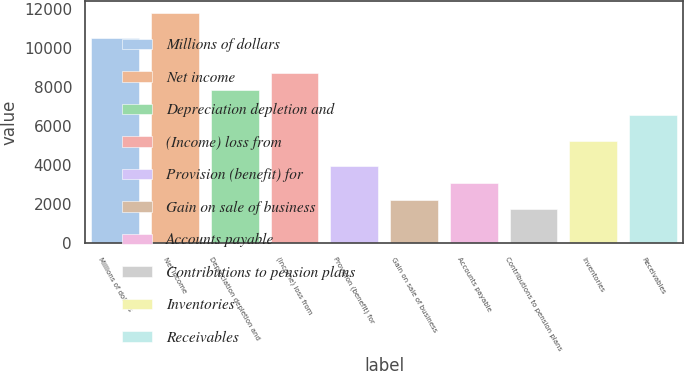<chart> <loc_0><loc_0><loc_500><loc_500><bar_chart><fcel>Millions of dollars<fcel>Net income<fcel>Depreciation depletion and<fcel>(Income) loss from<fcel>Provision (benefit) for<fcel>Gain on sale of business<fcel>Accounts payable<fcel>Contributions to pension plans<fcel>Inventories<fcel>Receivables<nl><fcel>10499.8<fcel>11811.4<fcel>7876.6<fcel>8751<fcel>3941.8<fcel>2193<fcel>3067.4<fcel>1755.8<fcel>5253.4<fcel>6565<nl></chart> 